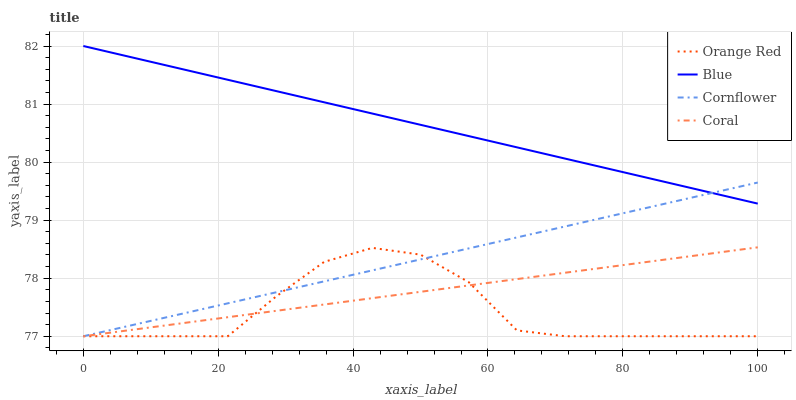Does Orange Red have the minimum area under the curve?
Answer yes or no. Yes. Does Blue have the maximum area under the curve?
Answer yes or no. Yes. Does Cornflower have the minimum area under the curve?
Answer yes or no. No. Does Cornflower have the maximum area under the curve?
Answer yes or no. No. Is Cornflower the smoothest?
Answer yes or no. Yes. Is Orange Red the roughest?
Answer yes or no. Yes. Is Coral the smoothest?
Answer yes or no. No. Is Coral the roughest?
Answer yes or no. No. Does Cornflower have the lowest value?
Answer yes or no. Yes. Does Blue have the highest value?
Answer yes or no. Yes. Does Cornflower have the highest value?
Answer yes or no. No. Is Coral less than Blue?
Answer yes or no. Yes. Is Blue greater than Coral?
Answer yes or no. Yes. Does Cornflower intersect Orange Red?
Answer yes or no. Yes. Is Cornflower less than Orange Red?
Answer yes or no. No. Is Cornflower greater than Orange Red?
Answer yes or no. No. Does Coral intersect Blue?
Answer yes or no. No. 